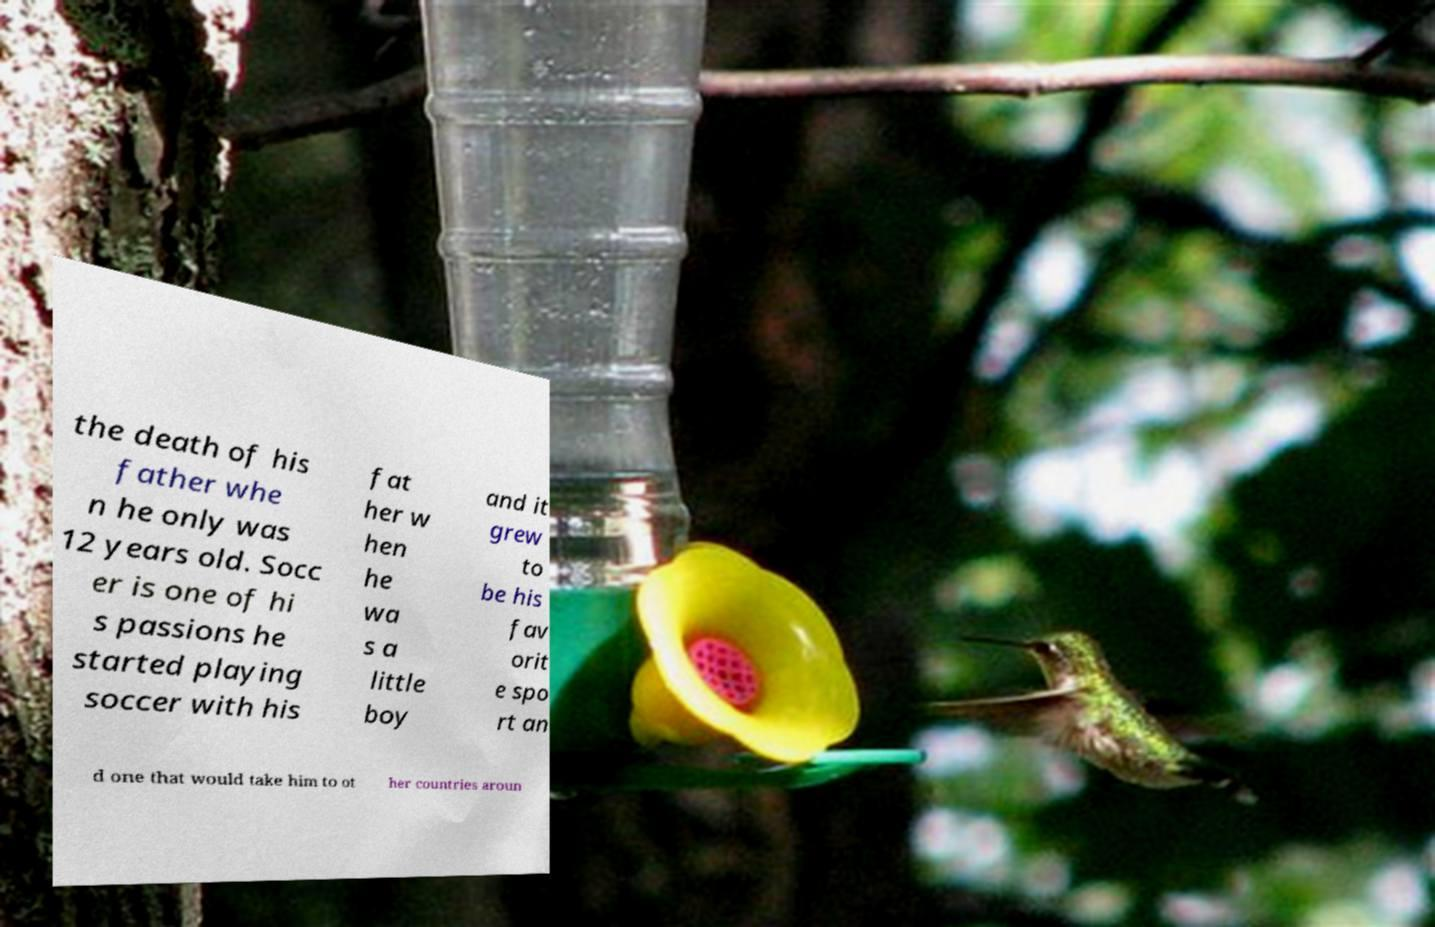Please identify and transcribe the text found in this image. the death of his father whe n he only was 12 years old. Socc er is one of hi s passions he started playing soccer with his fat her w hen he wa s a little boy and it grew to be his fav orit e spo rt an d one that would take him to ot her countries aroun 